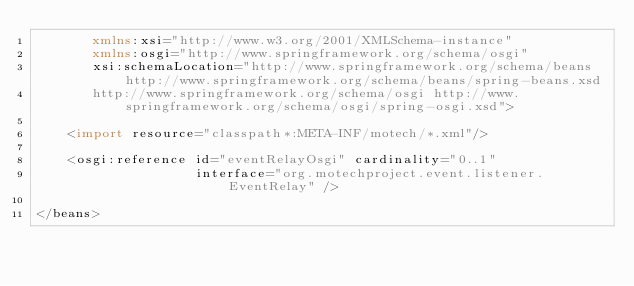<code> <loc_0><loc_0><loc_500><loc_500><_XML_>       xmlns:xsi="http://www.w3.org/2001/XMLSchema-instance"
       xmlns:osgi="http://www.springframework.org/schema/osgi"
       xsi:schemaLocation="http://www.springframework.org/schema/beans http://www.springframework.org/schema/beans/spring-beans.xsd
       http://www.springframework.org/schema/osgi http://www.springframework.org/schema/osgi/spring-osgi.xsd">

    <import resource="classpath*:META-INF/motech/*.xml"/>

    <osgi:reference id="eventRelayOsgi" cardinality="0..1"
                    interface="org.motechproject.event.listener.EventRelay" />

</beans></code> 